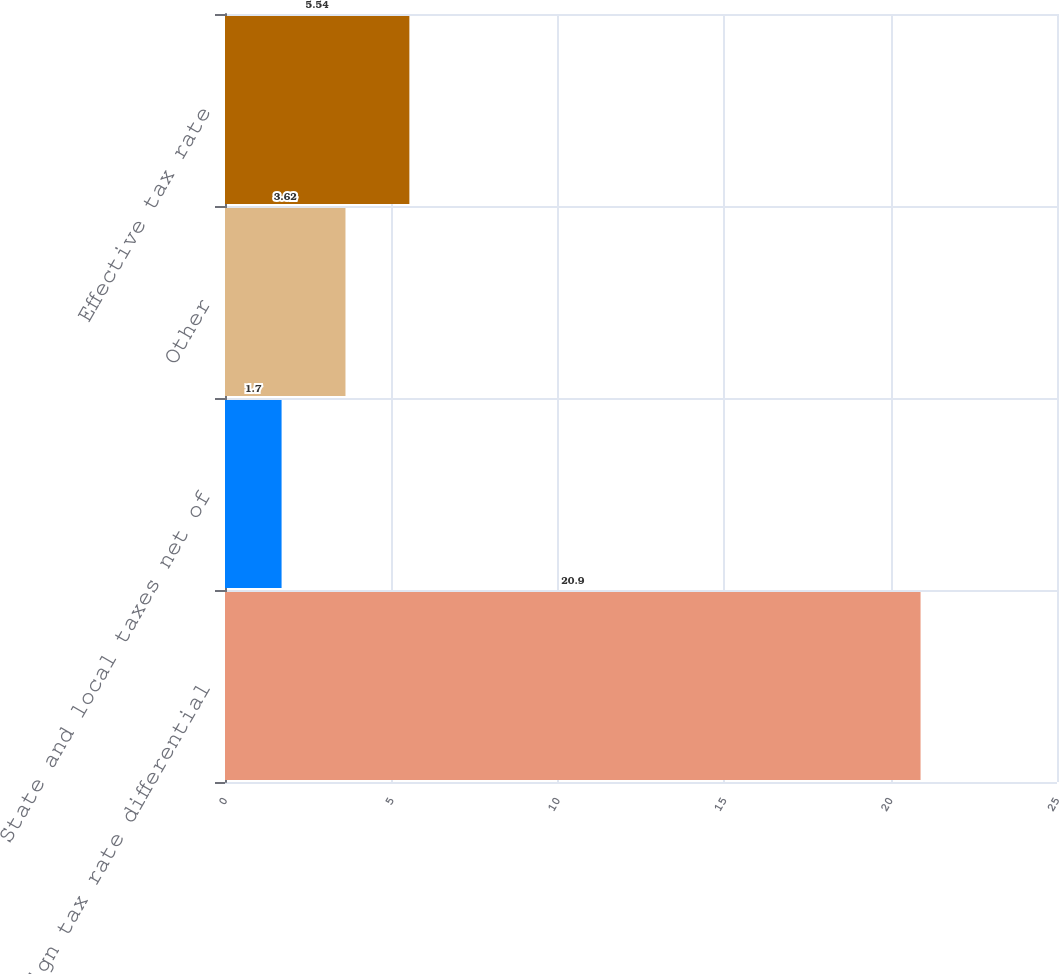<chart> <loc_0><loc_0><loc_500><loc_500><bar_chart><fcel>Foreign tax rate differential<fcel>State and local taxes net of<fcel>Other<fcel>Effective tax rate<nl><fcel>20.9<fcel>1.7<fcel>3.62<fcel>5.54<nl></chart> 